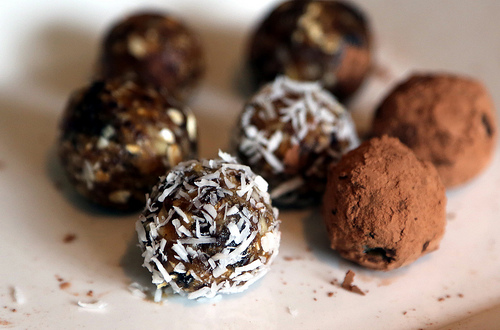<image>
Is there a sweets in the table? No. The sweets is not contained within the table. These objects have a different spatial relationship. 